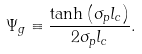<formula> <loc_0><loc_0><loc_500><loc_500>\Psi _ { g } \equiv \frac { \tanh \left ( \sigma _ { p } l _ { c } \right ) } { 2 \sigma _ { p } l _ { c } } .</formula> 